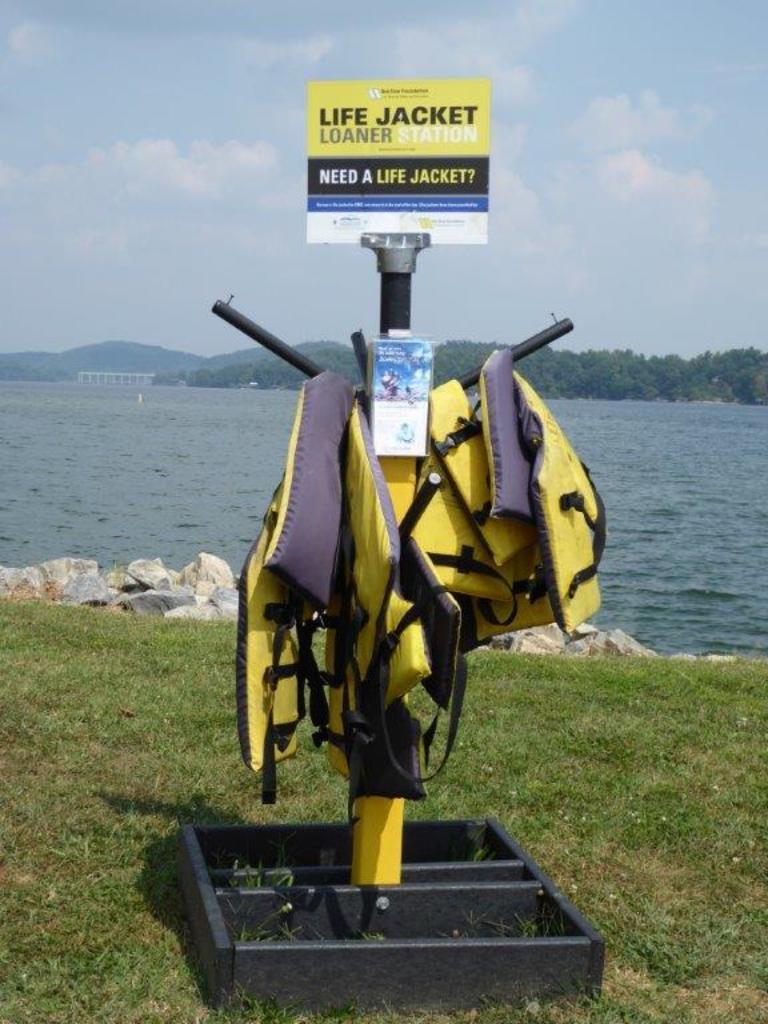Describe this image in one or two sentences. As we can see in the image, in the front there is a pole. On the pole there are yellow color jackets, grass, water and in the background there are lot of trees. On the top there is a sky and on the pole it was written "LIFE JACKET LOANER". 